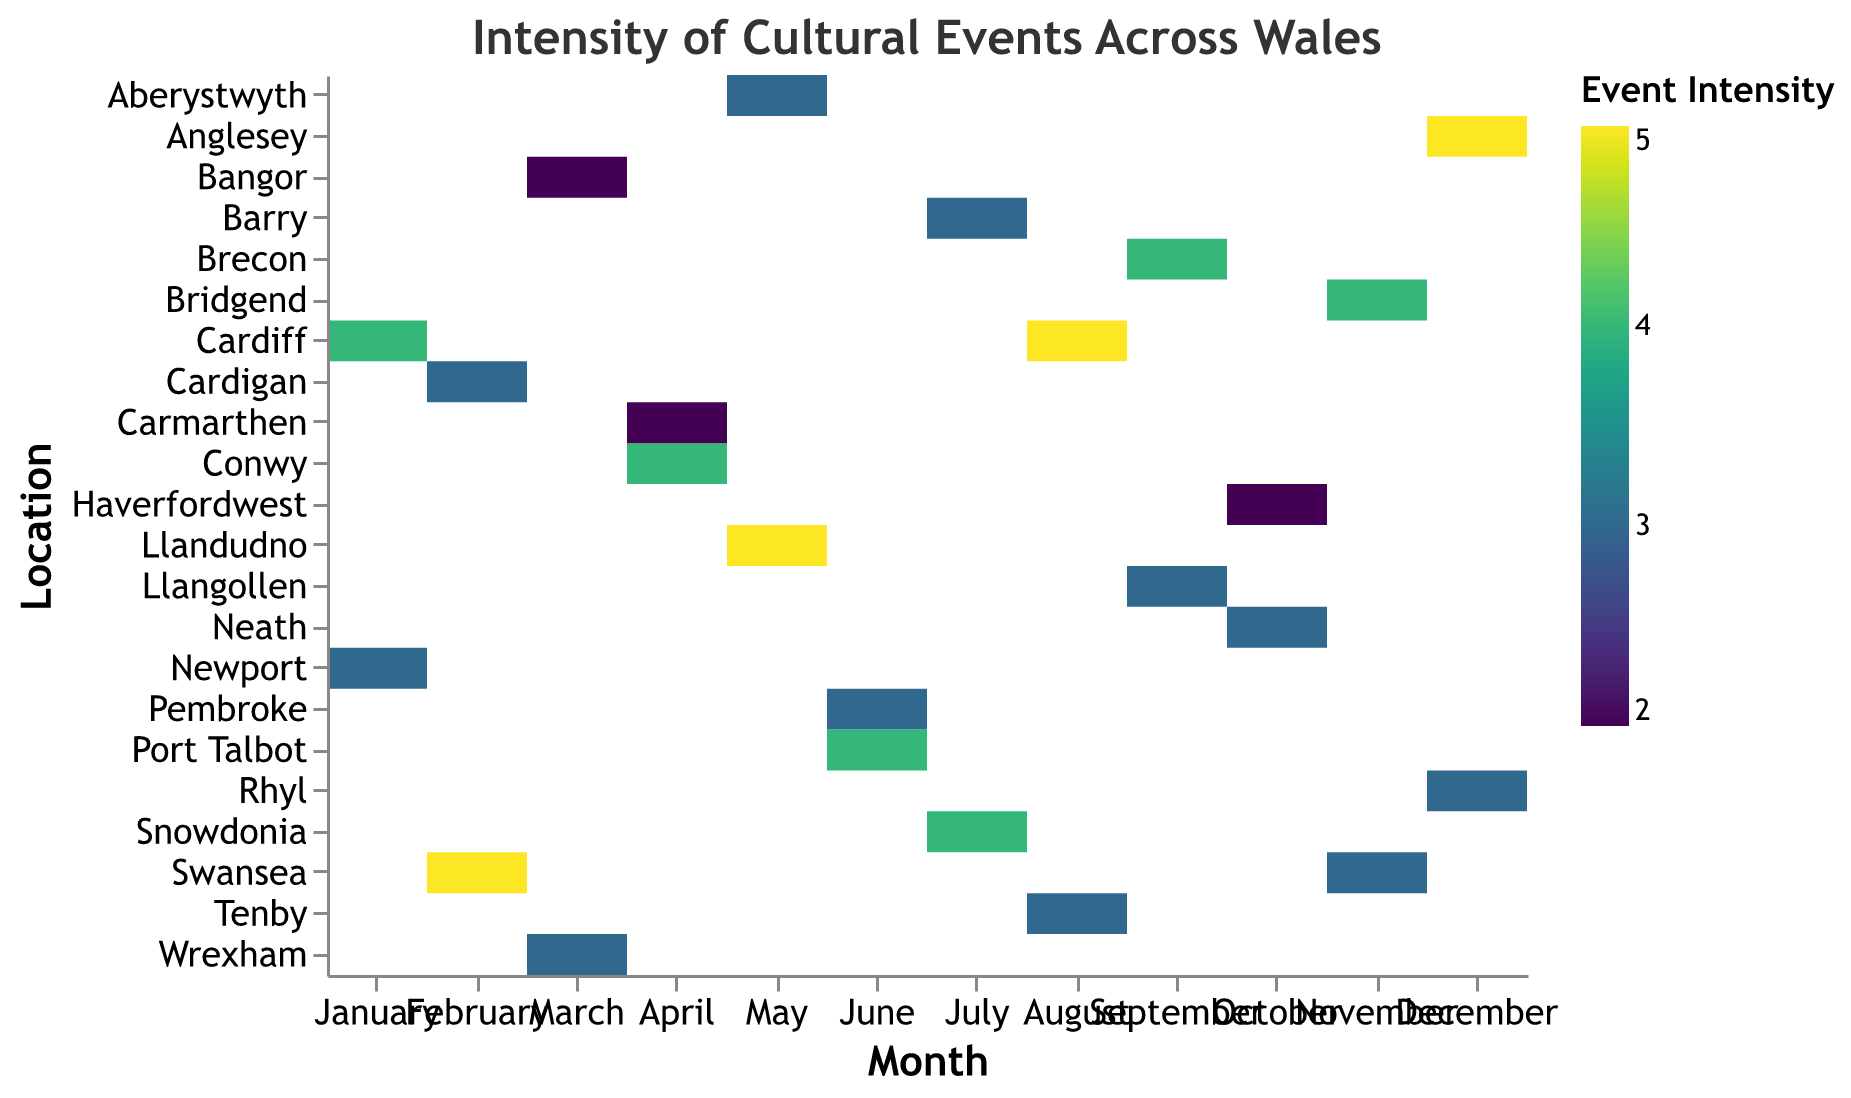What is the title of the heatmap? The title of the heatmap is located at the top and is written in larger, bold font. The title helps provide an overview of what the heatmap represents.
Answer: Intensity of Cultural Events Across Wales In which month does Cardiff host the event with the highest intensity? To determine which month Cardiff hosts the event with the highest intensity, look for the row corresponding to Cardiff and identify the month with the highest color intensity.
Answer: August What is the intensity of the Traditional Welsh Craft Fair in Newport? Look for the row that corresponds to Newport and the column for January. The intensity value will be shown as a color and a number with tooltip.
Answer: 3 Which event in December has the highest intensity, and where is it located? Identify the columns representing December. Compare the intensities of different rows in that column to find the highest one. Then, identify the event and its location.
Answer: Traditional Welsh Christmas Fair, Anglesey Which month and location has an event with the lowest intensity? To find the event with the lowest intensity, locate the part of the heatmap with the lightest color and trace it back to the corresponding month and location.
Answer: March, Bangor How many events have an intensity of 4? Count all the cells with the intensity value of 4 by looking at the color legend and matching it to the intensities in the heatmap.
Answer: 6 What is the average intensity of events in February? Identify the events in February and note their intensities. Sum these intensities and divide by the number of events (2) to find the average. The intensities are 5 and 3. (5 + 3) / 2 = 4.
Answer: 4 Compare the intensity of events in May and June. Which month has higher average intensity? Calculate the average intensity of events in each month by summing their intensities and dividing by the number of events. May has events with intensities 5 and 3 (average 4). June has events with intensities 4 and 3 (average 3.5).
Answer: May Which Welsh Gypsy-related event has the highest intensity and during which month does it occur? Identify all Welsh Gypsy-related events and find the highest intensity among them, then note the month it occurs. The highest intensity is 4 for Welsh Gypsy Music Festival in January.
Answer: January During which month is the intensity of Traditional Welsh Harvest Celebrations most noticeable? Find the month of September and look at the corresponding row for Traditional Welsh Harvest Celebrations. Notice the intensity value and compare it.
Answer: September 